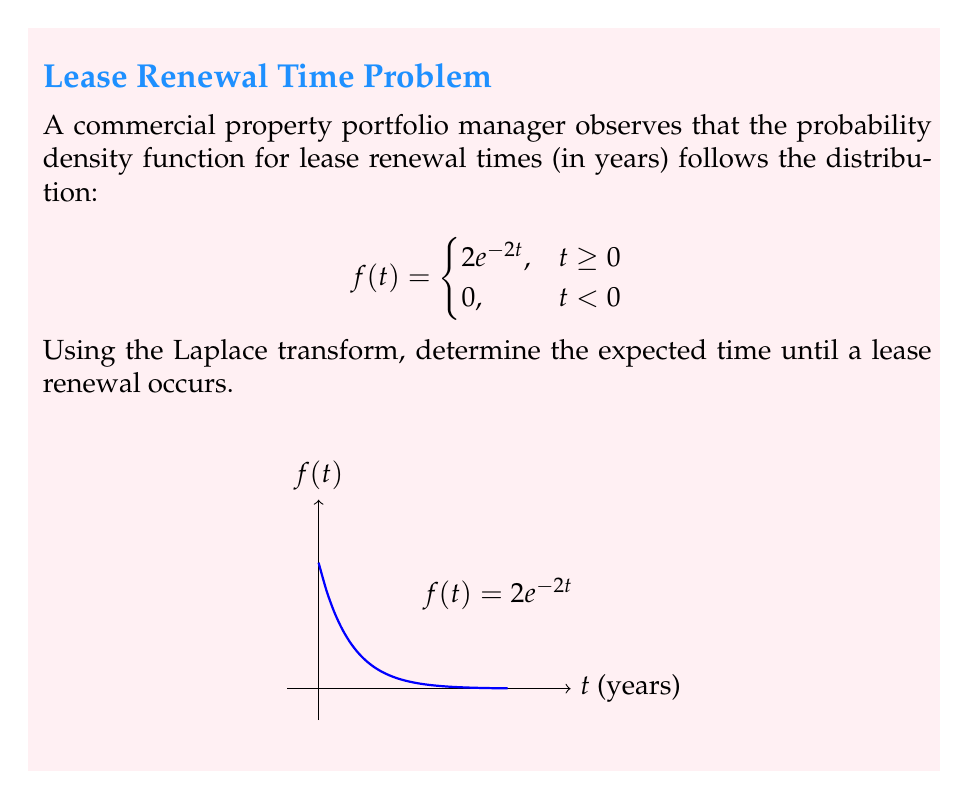Solve this math problem. To find the expected time until a lease renewal, we need to calculate $E[T]$, where $T$ is the random variable representing the time until renewal. For continuous distributions, $E[T] = \int_0^\infty t f(t) dt$.

We can use the Laplace transform to simplify this calculation:

1) The Laplace transform of $f(t)$ is given by:
   $$F(s) = \mathcal{L}\{f(t)\} = \int_0^\infty e^{-st} f(t) dt$$

2) For our specific $f(t) = 2e^{-2t}$, we have:
   $$F(s) = \int_0^\infty e^{-st} 2e^{-2t} dt = 2\int_0^\infty e^{-(s+2)t} dt = \frac{2}{s+2}$$

3) A property of the Laplace transform states that:
   $$E[T] = -\frac{d}{ds}F(s)\bigg|_{s=0}$$

4) Let's differentiate $F(s)$:
   $$\frac{d}{ds}F(s) = \frac{d}{ds}\left(\frac{2}{s+2}\right) = -\frac{2}{(s+2)^2}$$

5) Now, we evaluate this at $s=0$:
   $$E[T] = -\left(-\frac{2}{(0+2)^2}\right) = \frac{2}{4} = \frac{1}{2}$$

Therefore, the expected time until a lease renewal occurs is 0.5 years or 6 months.
Answer: $E[T] = \frac{1}{2}$ years 